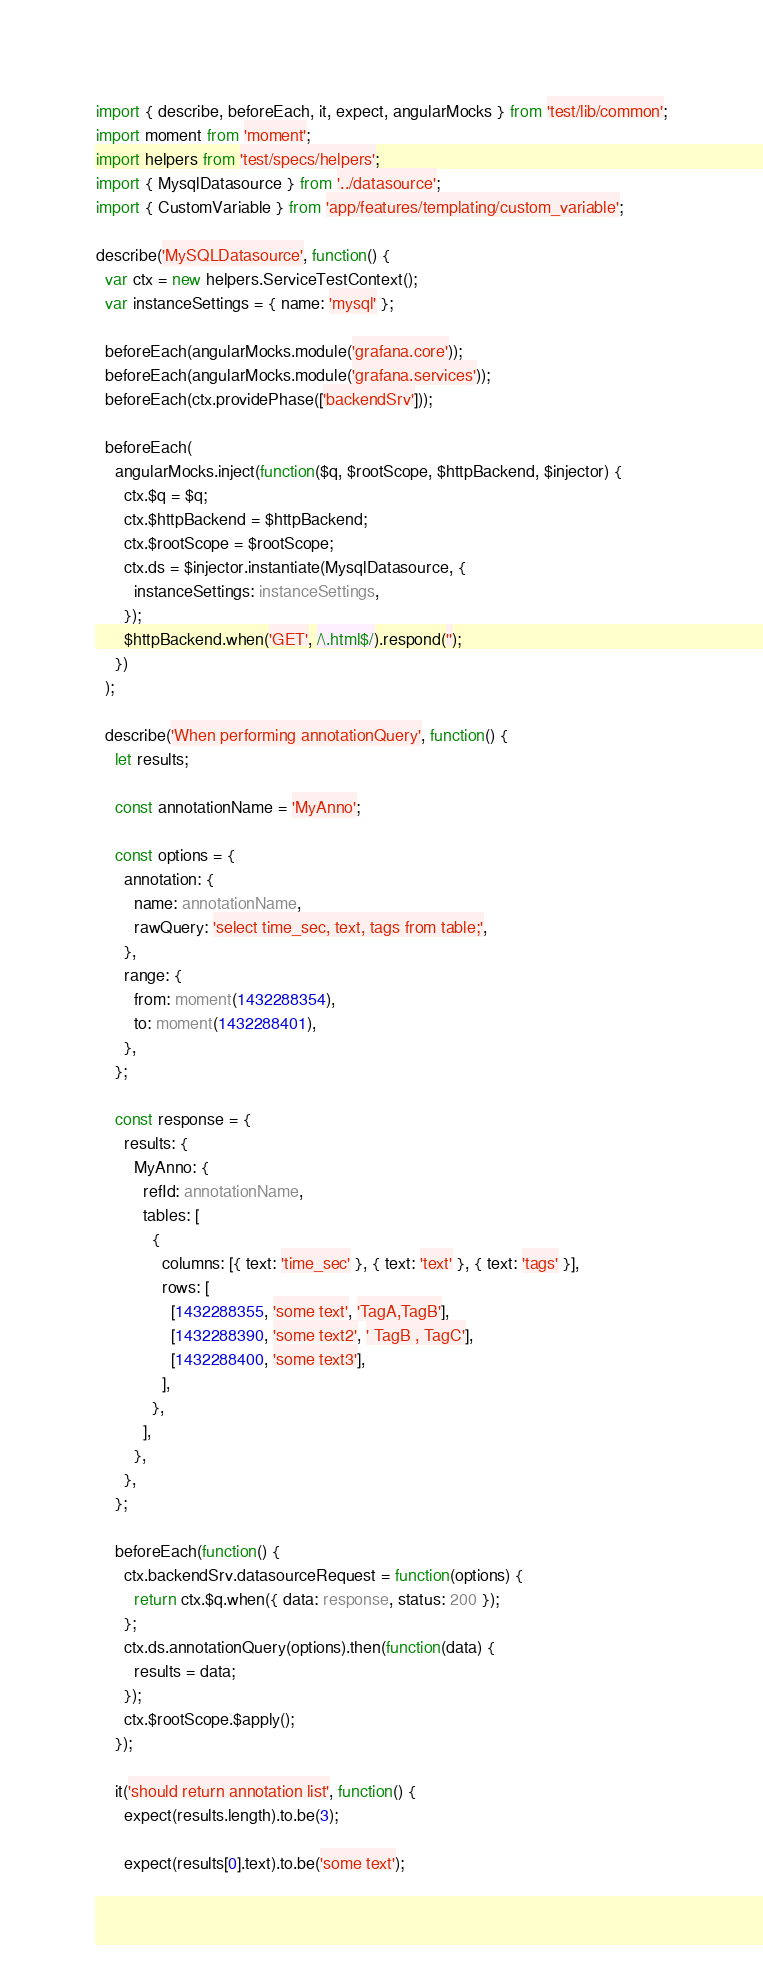<code> <loc_0><loc_0><loc_500><loc_500><_TypeScript_>import { describe, beforeEach, it, expect, angularMocks } from 'test/lib/common';
import moment from 'moment';
import helpers from 'test/specs/helpers';
import { MysqlDatasource } from '../datasource';
import { CustomVariable } from 'app/features/templating/custom_variable';

describe('MySQLDatasource', function() {
  var ctx = new helpers.ServiceTestContext();
  var instanceSettings = { name: 'mysql' };

  beforeEach(angularMocks.module('grafana.core'));
  beforeEach(angularMocks.module('grafana.services'));
  beforeEach(ctx.providePhase(['backendSrv']));

  beforeEach(
    angularMocks.inject(function($q, $rootScope, $httpBackend, $injector) {
      ctx.$q = $q;
      ctx.$httpBackend = $httpBackend;
      ctx.$rootScope = $rootScope;
      ctx.ds = $injector.instantiate(MysqlDatasource, {
        instanceSettings: instanceSettings,
      });
      $httpBackend.when('GET', /\.html$/).respond('');
    })
  );

  describe('When performing annotationQuery', function() {
    let results;

    const annotationName = 'MyAnno';

    const options = {
      annotation: {
        name: annotationName,
        rawQuery: 'select time_sec, text, tags from table;',
      },
      range: {
        from: moment(1432288354),
        to: moment(1432288401),
      },
    };

    const response = {
      results: {
        MyAnno: {
          refId: annotationName,
          tables: [
            {
              columns: [{ text: 'time_sec' }, { text: 'text' }, { text: 'tags' }],
              rows: [
                [1432288355, 'some text', 'TagA,TagB'],
                [1432288390, 'some text2', ' TagB , TagC'],
                [1432288400, 'some text3'],
              ],
            },
          ],
        },
      },
    };

    beforeEach(function() {
      ctx.backendSrv.datasourceRequest = function(options) {
        return ctx.$q.when({ data: response, status: 200 });
      };
      ctx.ds.annotationQuery(options).then(function(data) {
        results = data;
      });
      ctx.$rootScope.$apply();
    });

    it('should return annotation list', function() {
      expect(results.length).to.be(3);

      expect(results[0].text).to.be('some text');</code> 